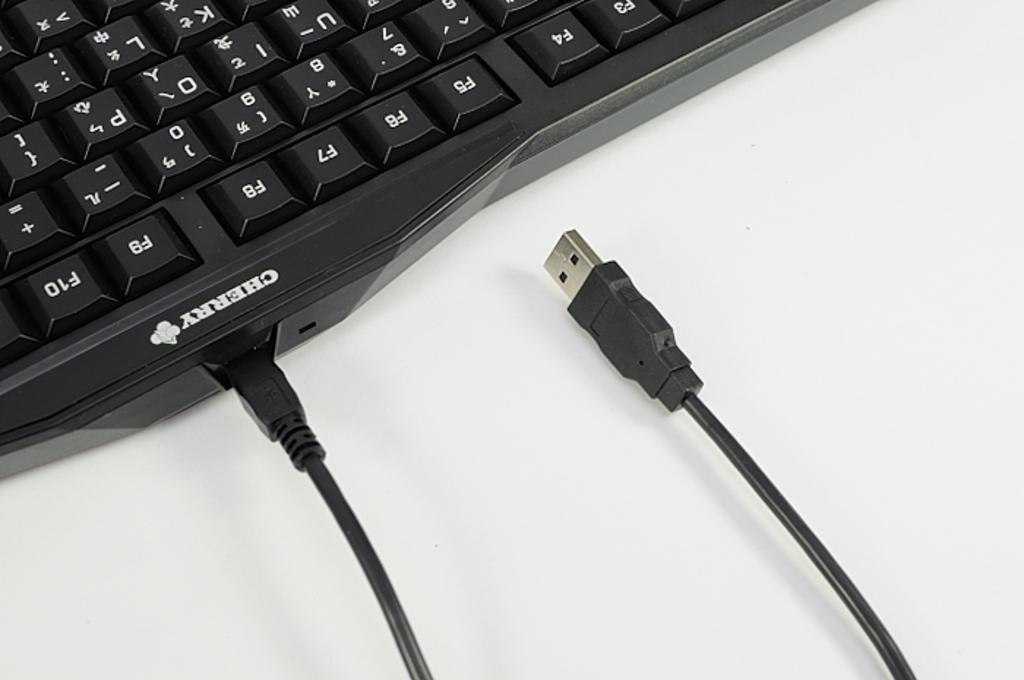<image>
Share a concise interpretation of the image provided. a cherry brand keyboard with a cable coming out of it 